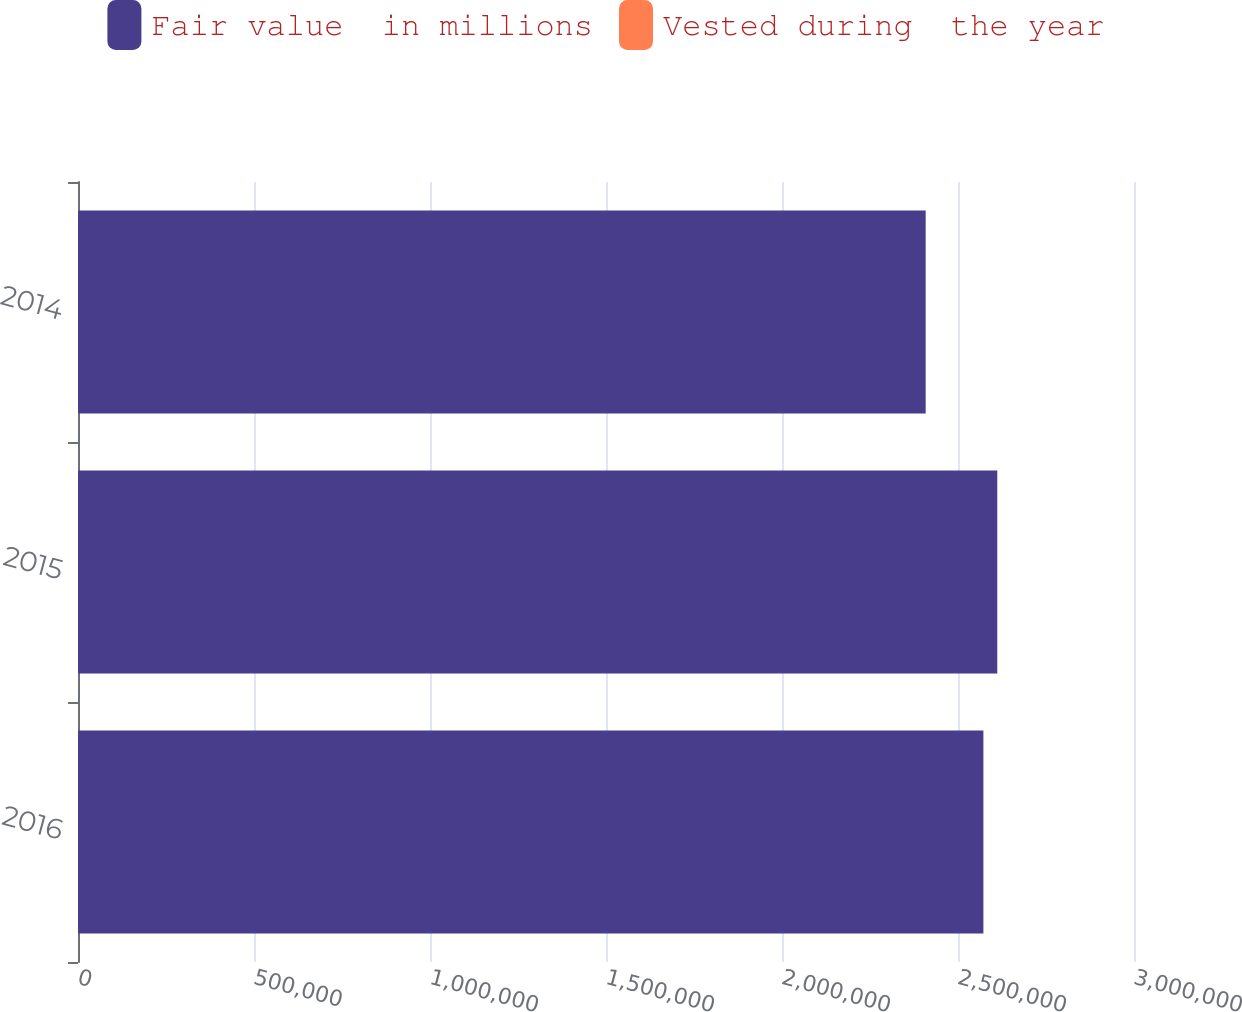Convert chart. <chart><loc_0><loc_0><loc_500><loc_500><stacked_bar_chart><ecel><fcel>2016<fcel>2015<fcel>2014<nl><fcel>Fair value  in millions<fcel>2.57213e+06<fcel>2.61152e+06<fcel>2.40818e+06<nl><fcel>Vested during  the year<fcel>98<fcel>83<fcel>65<nl></chart> 